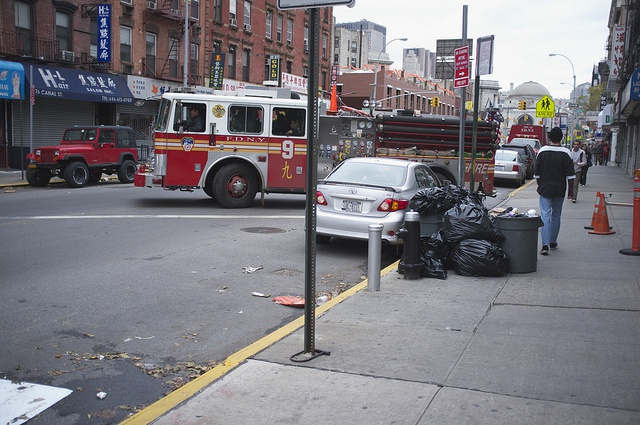Describe the objects in this image and their specific colors. I can see truck in black, gray, maroon, and darkgray tones, car in black, lightgray, darkgray, and gray tones, car in black, maroon, and gray tones, people in black and gray tones, and fire hydrant in black, gray, darkgray, and lightgray tones in this image. 